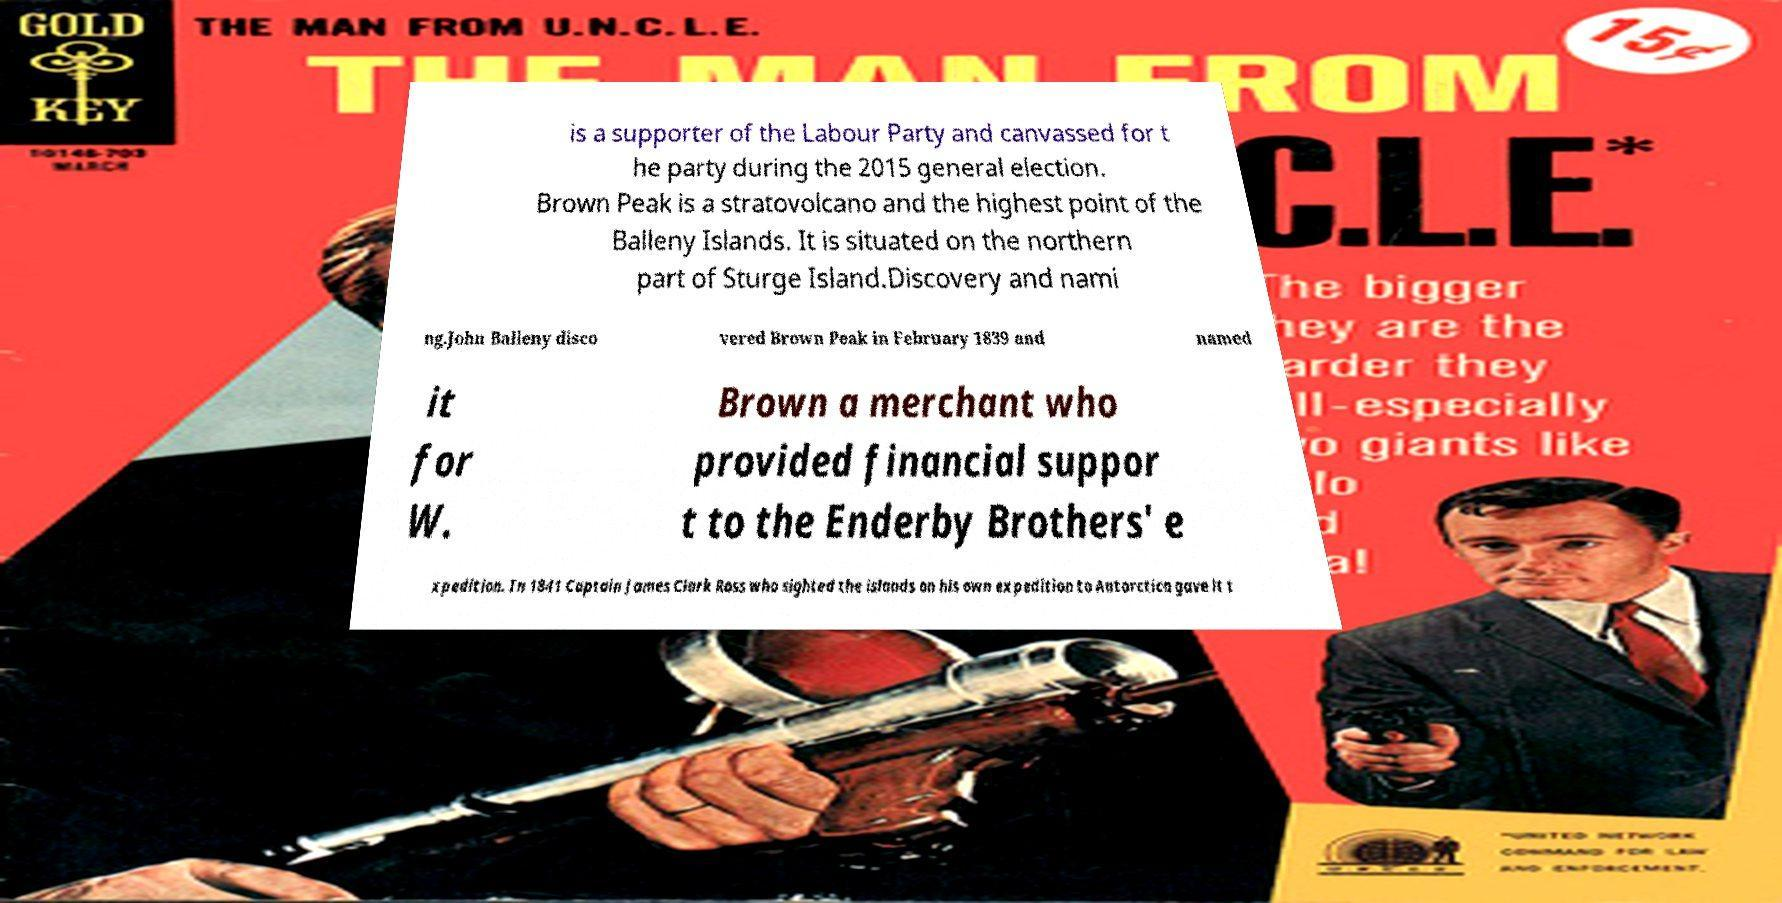What messages or text are displayed in this image? I need them in a readable, typed format. is a supporter of the Labour Party and canvassed for t he party during the 2015 general election. Brown Peak is a stratovolcano and the highest point of the Balleny Islands. It is situated on the northern part of Sturge Island.Discovery and nami ng.John Balleny disco vered Brown Peak in February 1839 and named it for W. Brown a merchant who provided financial suppor t to the Enderby Brothers' e xpedition. In 1841 Captain James Clark Ross who sighted the islands on his own expedition to Antarctica gave it t 